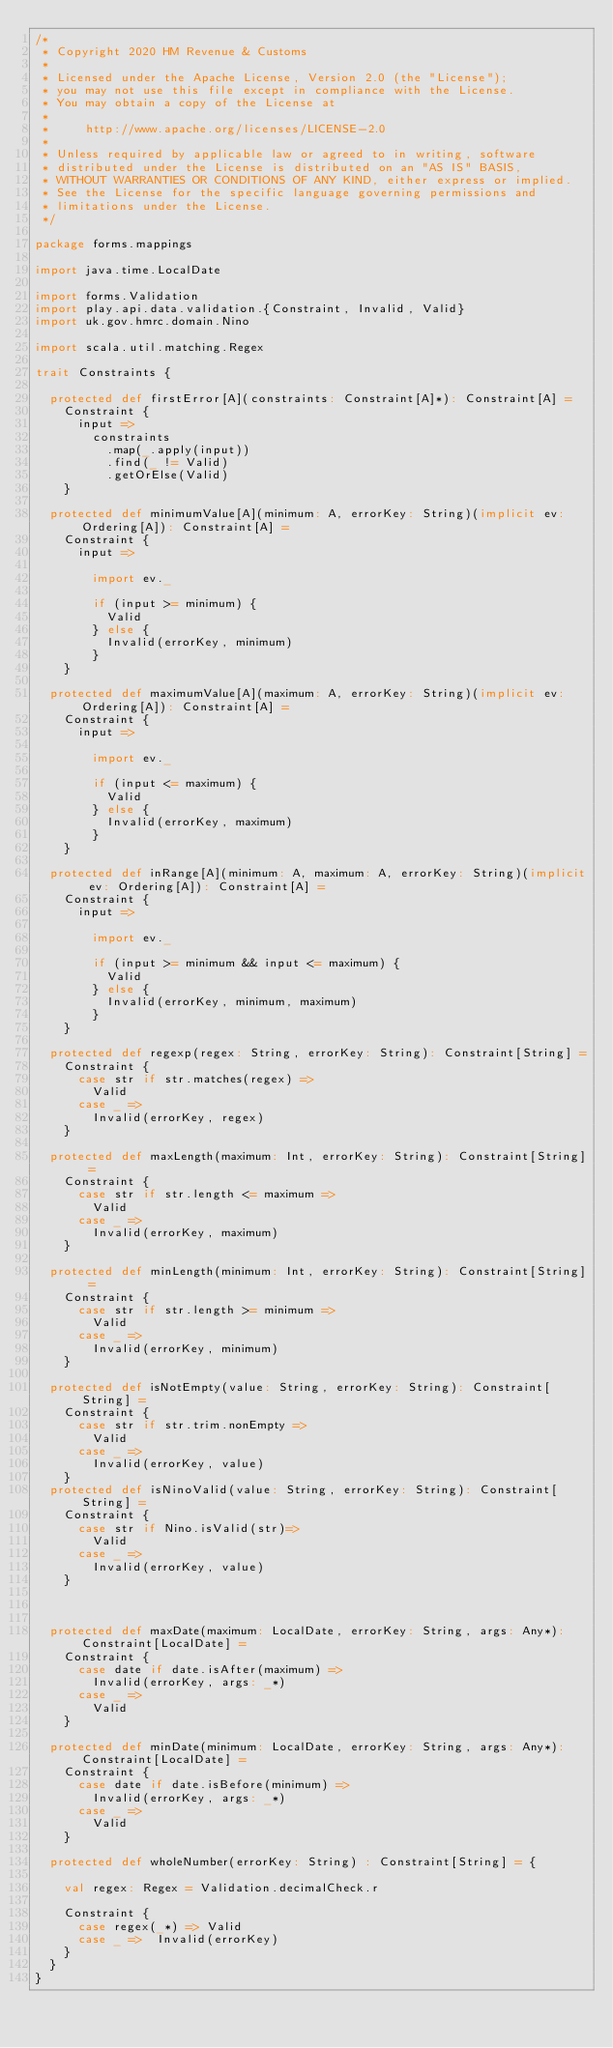<code> <loc_0><loc_0><loc_500><loc_500><_Scala_>/*
 * Copyright 2020 HM Revenue & Customs
 *
 * Licensed under the Apache License, Version 2.0 (the "License");
 * you may not use this file except in compliance with the License.
 * You may obtain a copy of the License at
 *
 *     http://www.apache.org/licenses/LICENSE-2.0
 *
 * Unless required by applicable law or agreed to in writing, software
 * distributed under the License is distributed on an "AS IS" BASIS,
 * WITHOUT WARRANTIES OR CONDITIONS OF ANY KIND, either express or implied.
 * See the License for the specific language governing permissions and
 * limitations under the License.
 */

package forms.mappings

import java.time.LocalDate

import forms.Validation
import play.api.data.validation.{Constraint, Invalid, Valid}
import uk.gov.hmrc.domain.Nino

import scala.util.matching.Regex

trait Constraints {

  protected def firstError[A](constraints: Constraint[A]*): Constraint[A] =
    Constraint {
      input =>
        constraints
          .map(_.apply(input))
          .find(_ != Valid)
          .getOrElse(Valid)
    }

  protected def minimumValue[A](minimum: A, errorKey: String)(implicit ev: Ordering[A]): Constraint[A] =
    Constraint {
      input =>

        import ev._

        if (input >= minimum) {
          Valid
        } else {
          Invalid(errorKey, minimum)
        }
    }

  protected def maximumValue[A](maximum: A, errorKey: String)(implicit ev: Ordering[A]): Constraint[A] =
    Constraint {
      input =>

        import ev._

        if (input <= maximum) {
          Valid
        } else {
          Invalid(errorKey, maximum)
        }
    }

  protected def inRange[A](minimum: A, maximum: A, errorKey: String)(implicit ev: Ordering[A]): Constraint[A] =
    Constraint {
      input =>

        import ev._

        if (input >= minimum && input <= maximum) {
          Valid
        } else {
          Invalid(errorKey, minimum, maximum)
        }
    }

  protected def regexp(regex: String, errorKey: String): Constraint[String] =
    Constraint {
      case str if str.matches(regex) =>
        Valid
      case _ =>
        Invalid(errorKey, regex)
    }

  protected def maxLength(maximum: Int, errorKey: String): Constraint[String] =
    Constraint {
      case str if str.length <= maximum =>
        Valid
      case _ =>
        Invalid(errorKey, maximum)
    }

  protected def minLength(minimum: Int, errorKey: String): Constraint[String] =
    Constraint {
      case str if str.length >= minimum =>
        Valid
      case _ =>
        Invalid(errorKey, minimum)
    }

  protected def isNotEmpty(value: String, errorKey: String): Constraint[String] =
    Constraint {
      case str if str.trim.nonEmpty =>
        Valid
      case _ =>
        Invalid(errorKey, value)
    }
  protected def isNinoValid(value: String, errorKey: String): Constraint[String] =
    Constraint {
      case str if Nino.isValid(str)=>
        Valid
      case _ =>
        Invalid(errorKey, value)
    }



  protected def maxDate(maximum: LocalDate, errorKey: String, args: Any*): Constraint[LocalDate] =
    Constraint {
      case date if date.isAfter(maximum) =>
        Invalid(errorKey, args: _*)
      case _ =>
        Valid
    }

  protected def minDate(minimum: LocalDate, errorKey: String, args: Any*): Constraint[LocalDate] =
    Constraint {
      case date if date.isBefore(minimum) =>
        Invalid(errorKey, args: _*)
      case _ =>
        Valid
    }

  protected def wholeNumber(errorKey: String) : Constraint[String] = {

    val regex: Regex = Validation.decimalCheck.r

    Constraint {
      case regex(_*) => Valid
      case _ =>  Invalid(errorKey)
    }
  }
}
</code> 